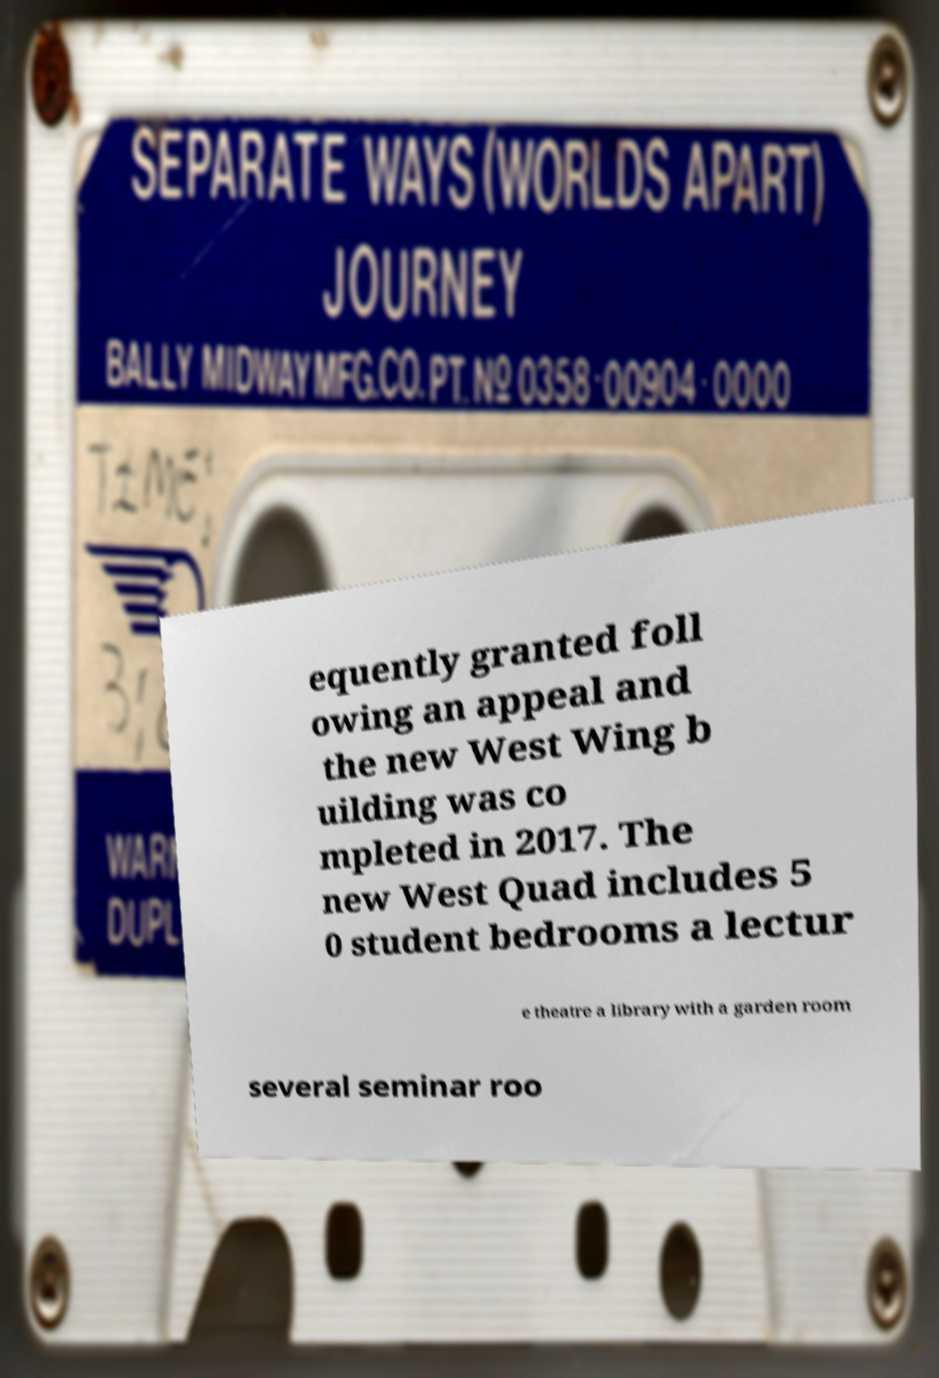Can you read and provide the text displayed in the image?This photo seems to have some interesting text. Can you extract and type it out for me? equently granted foll owing an appeal and the new West Wing b uilding was co mpleted in 2017. The new West Quad includes 5 0 student bedrooms a lectur e theatre a library with a garden room several seminar roo 